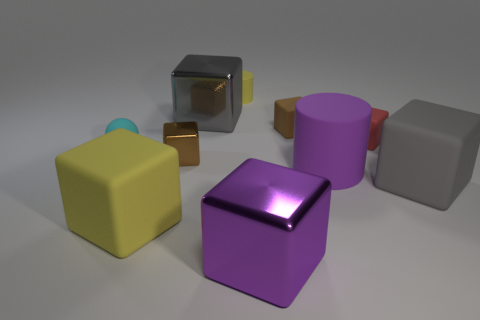Subtract all brown blocks. How many blocks are left? 5 Subtract all metallic cubes. How many cubes are left? 4 Subtract all yellow cubes. Subtract all cyan balls. How many cubes are left? 6 Subtract all blocks. How many objects are left? 3 Add 8 big red metallic things. How many big red metallic things exist? 8 Subtract 1 yellow blocks. How many objects are left? 9 Subtract all gray metal cubes. Subtract all purple objects. How many objects are left? 7 Add 7 cyan matte spheres. How many cyan matte spheres are left? 8 